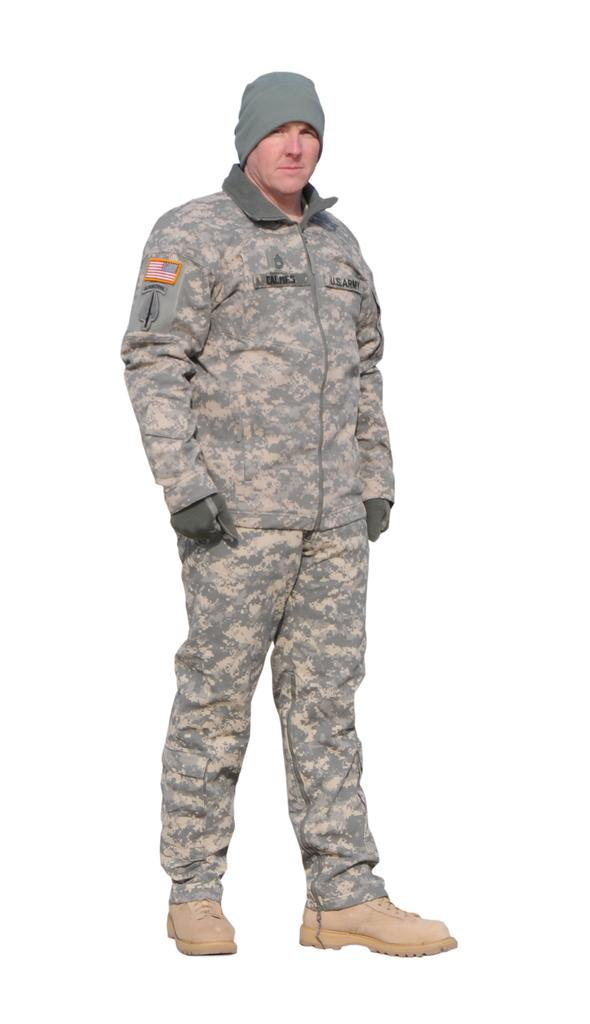Who is present in the image? There is a man in the image. What is the man wearing on his head? The man is wearing a cap. What type of clothing is the man wearing? The man is wearing a camp fire dress. What type of hand protection is the man wearing? The man is wearing gloves. What type of footwear is the man wearing? The man is wearing shoes. What type of toad can be seen sitting on the man's shoulder in the image? There is no toad present in the image; the man is not accompanied by any animals. 